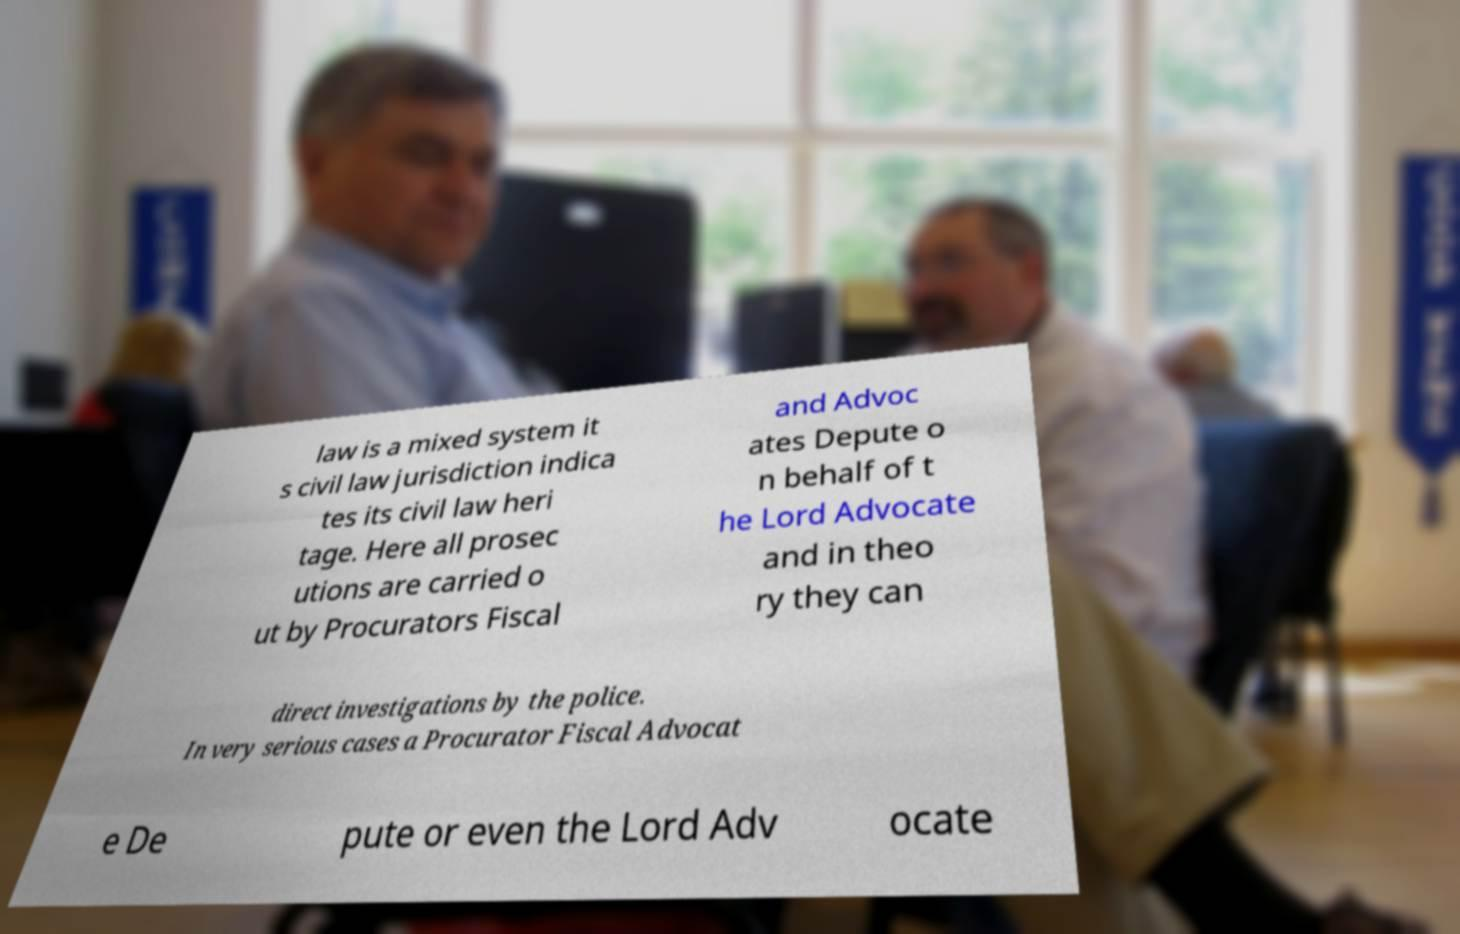Can you read and provide the text displayed in the image?This photo seems to have some interesting text. Can you extract and type it out for me? law is a mixed system it s civil law jurisdiction indica tes its civil law heri tage. Here all prosec utions are carried o ut by Procurators Fiscal and Advoc ates Depute o n behalf of t he Lord Advocate and in theo ry they can direct investigations by the police. In very serious cases a Procurator Fiscal Advocat e De pute or even the Lord Adv ocate 